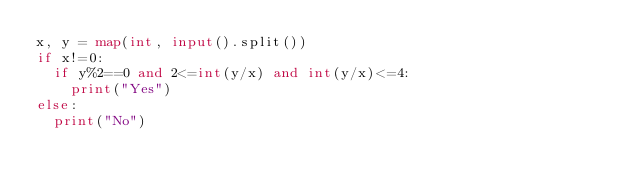Convert code to text. <code><loc_0><loc_0><loc_500><loc_500><_Python_>x, y = map(int, input().split())
if x!=0:
  if y%2==0 and 2<=int(y/x) and int(y/x)<=4:
    print("Yes")
else:
  print("No")</code> 